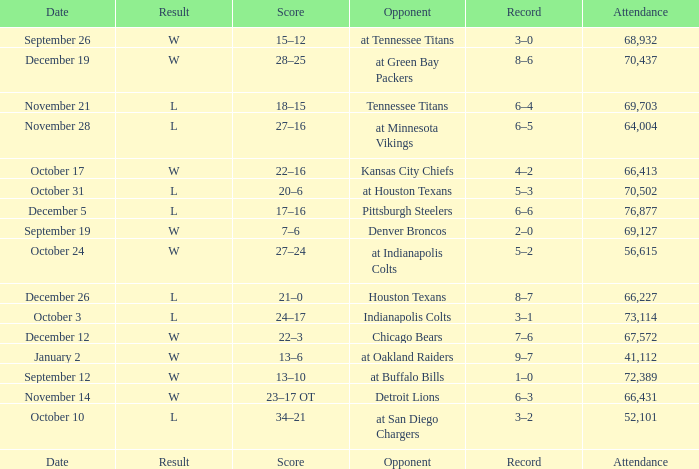What score has houston texans as the opponent? 21–0. 